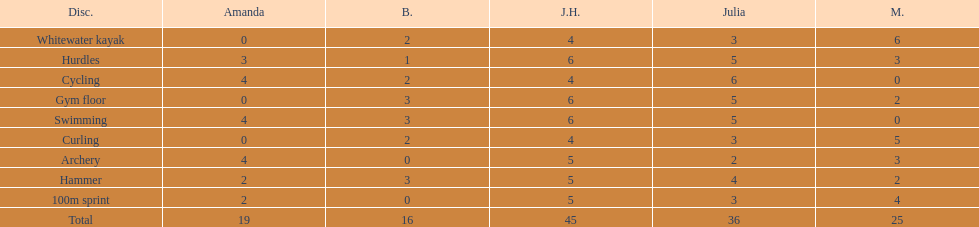Who had her best score in cycling? Julia. 